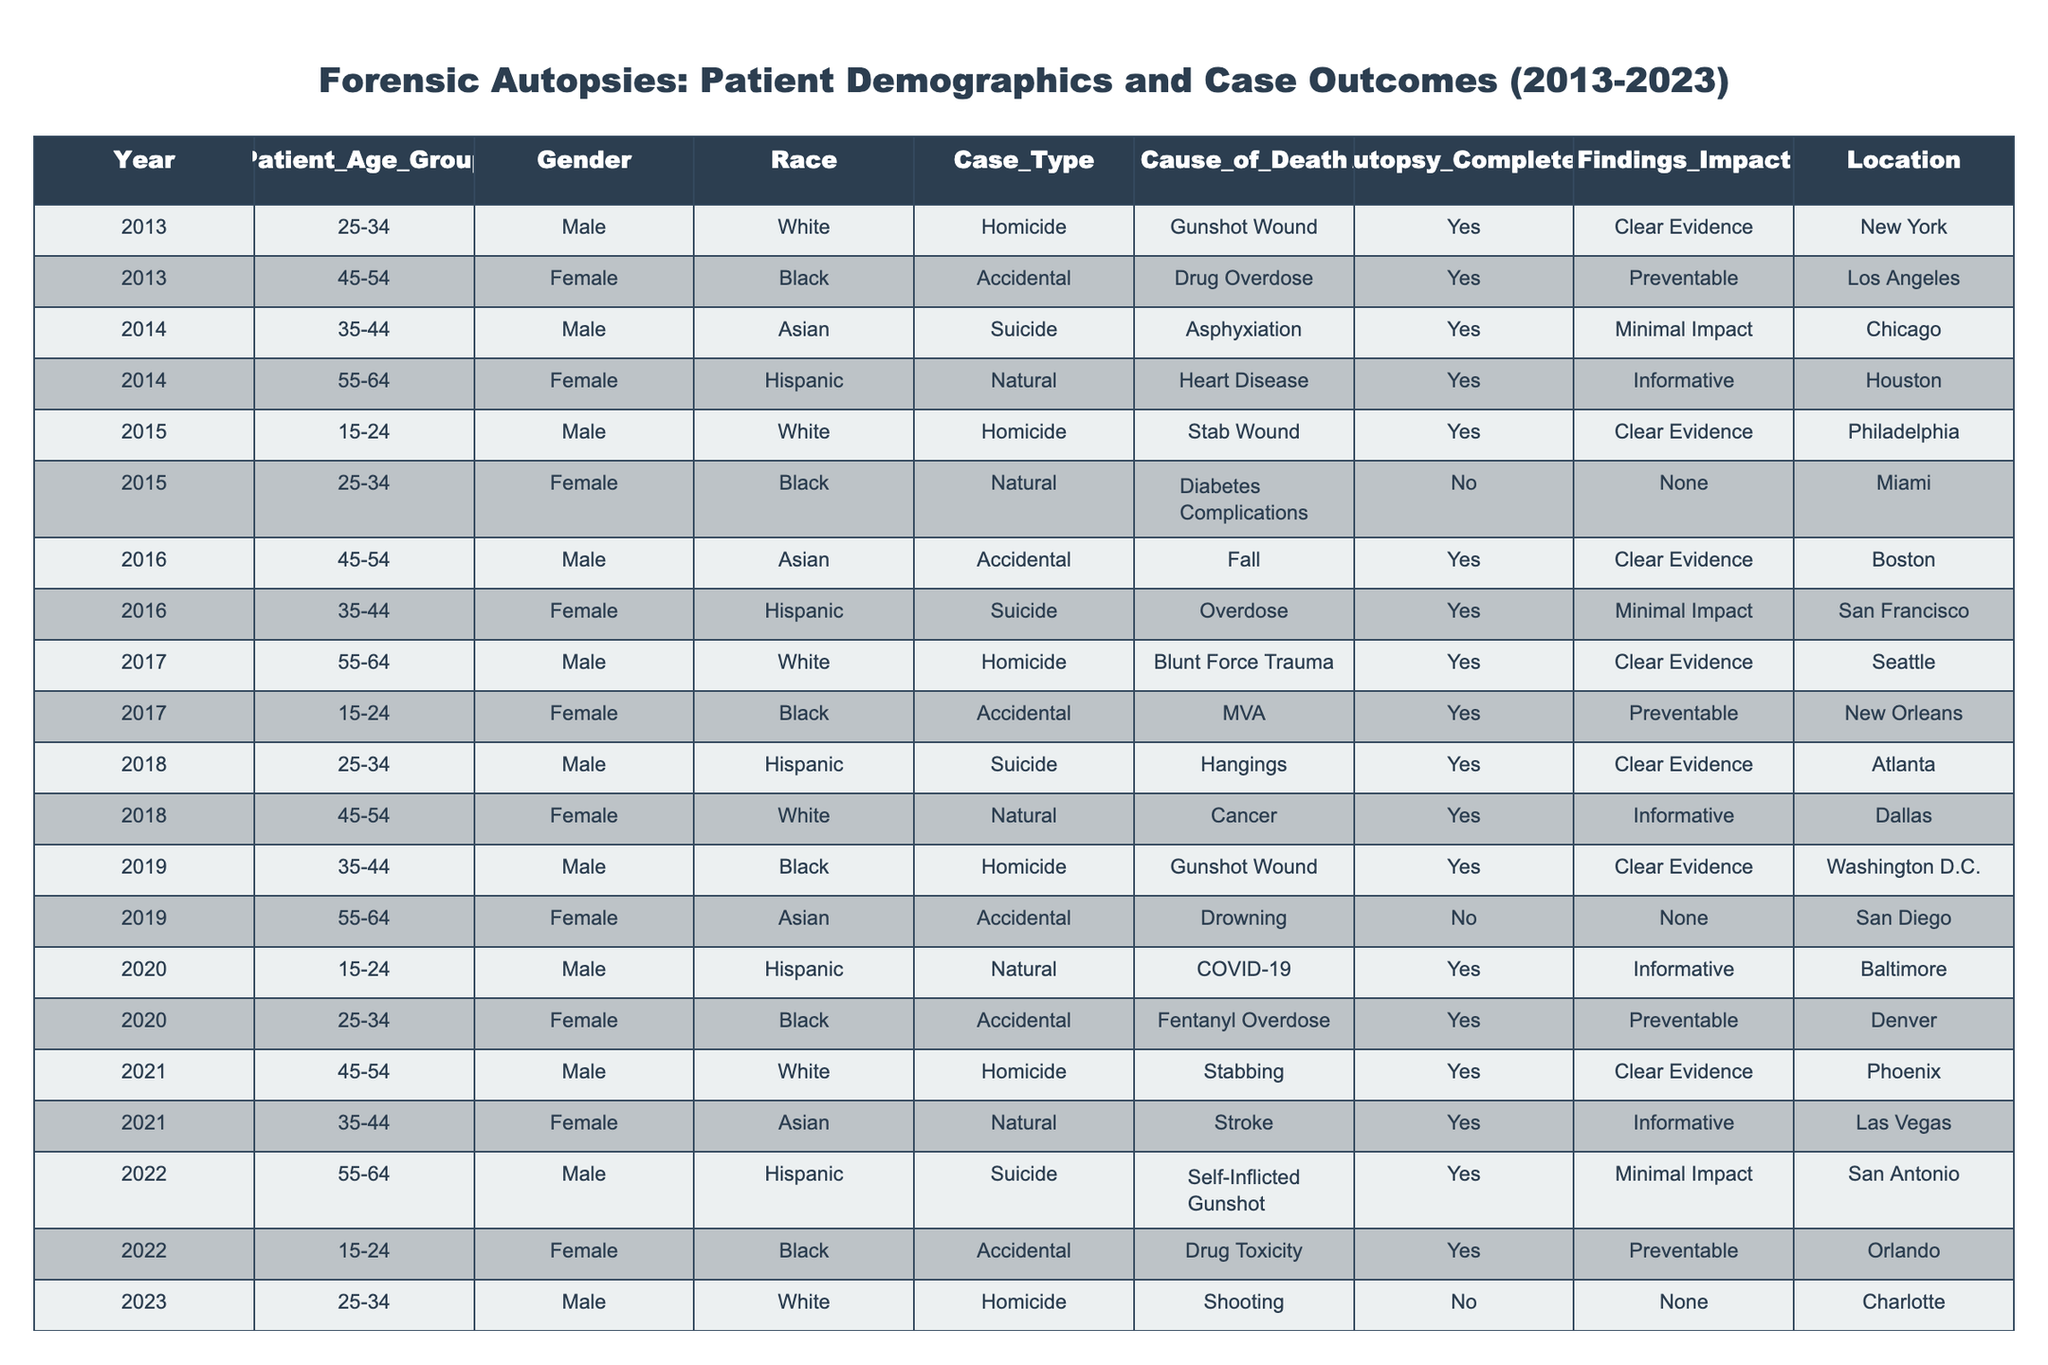What is the total number of forensic autopsies completed in 2020? In 2020, there are two cases listed in the table, and both indicate that an autopsy was completed.
Answer: 2 Which age group has the highest number of homicide cases recorded? By looking through the table, we see that both the 25-34 and 15-24 age groups have two cases of homicides each.
Answer: 25-34 and 15-24 What percentage of cases in 2015 were completed with autopsy findings having a clear evidence impact? In 2015, there are two cases: one has clear evidence, and one does not. The percentage of cases with clear evidence is (1/2) * 100 = 50%.
Answer: 50% How many total cases were classified as accidental deaths from 2013 to 2023? By reviewing the table, I count four cases under the Accidental classification from various years.
Answer: 4 Is there any case where the autopsy was not completed for a homicide? In the table, the only listed homicide case without a completed autopsy is from 2023.
Answer: Yes What is the most common cause of death among females in the dataset? Upon examining the dataset, I find the most frequent cause of death among females is "Natural" with three occurrences (Heart Disease, Cancer, Stroke).
Answer: Natural How many total cases had findings that were classified as informative? I check the cases labeled as 'Informative' and find that there are four such instances across the dataset.
Answer: 4 What is the difference in the number of suicides and homicides recorded in 2018? In 2018, there is one case of suicide and one case of homicide. Hence, the difference is 1 - 1 = 0.
Answer: 0 Which gender experienced the most accidental deaths, and how many cases are recorded? Reviewing the table, I find that there are two accidental deaths for females and two for males, which means both genders are tied with two cases each.
Answer: Tie, 2 cases each In which year was the highest number of cases completed that had clear evidence findings? Analyzing the years, I find that 2013 and 2017 both have three cases with clear evidence findings, which is the highest count.
Answer: 2013 and 2017 